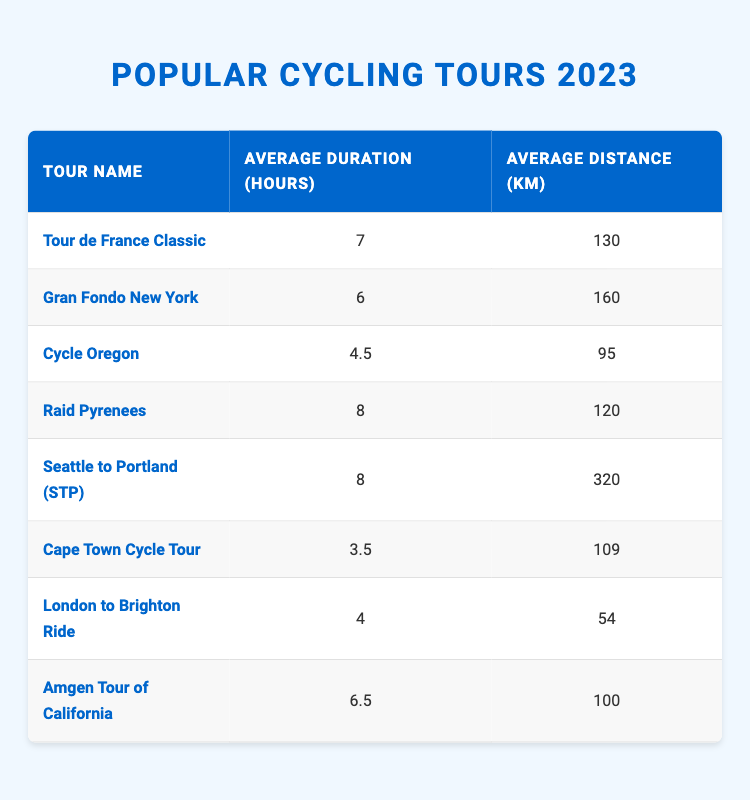What is the average duration of the "Gran Fondo New York" tour? The average duration for the "Gran Fondo New York" tour is listed directly in the table, which shows it as 6 hours.
Answer: 6 hours What is the average distance of the "Cape Town Cycle Tour"? The average distance for the "Cape Town Cycle Tour" is also directly available in the table, which shows it as 109 km.
Answer: 109 km Which tour has the longest average duration? By examining the average durations in the table, the "Raid Pyrenees" and "Seattle to Portland (STP)" tours both have the longest average durations at 8 hours.
Answer: Raid Pyrenees and Seattle to Portland (STP) What is the combined average distance of the "London to Brighton Ride" and "Cycle Oregon"? To find the combined average distance, we add the distances: "London to Brighton Ride" = 54 km and "Cycle Oregon" = 95 km. The sum is 54 + 95 = 149 km.
Answer: 149 km Is the average distance for "Tour de France Classic" greater than 120 km? The average distance for the "Tour de France Classic" is 130 km, which is greater than 120 km, confirming a yes.
Answer: Yes What is the average duration of all the tours listed? To find the average duration, sum the durations: 7 + 6 + 4.5 + 8 + 8 + 3.5 + 4 + 6.5 = 43.5 hours. There are 8 tours, so the average is 43.5 / 8 = 5.4375 hours, which can be rounded to 5.44 hours.
Answer: 5.44 hours Does "Amgen Tour of California" have an average distance of more than 100 km? The average distance for "Amgen Tour of California" is listed as 100 km, which does not exceed 100 km, confirming a no.
Answer: No How many tours have an average distance of less than 100 km? By examining the average distances, the tours with less than 100 km are "Cycle Oregon" (95 km) and "London to Brighton Ride" (54 km), making it a total of 2 tours.
Answer: 2 tours 